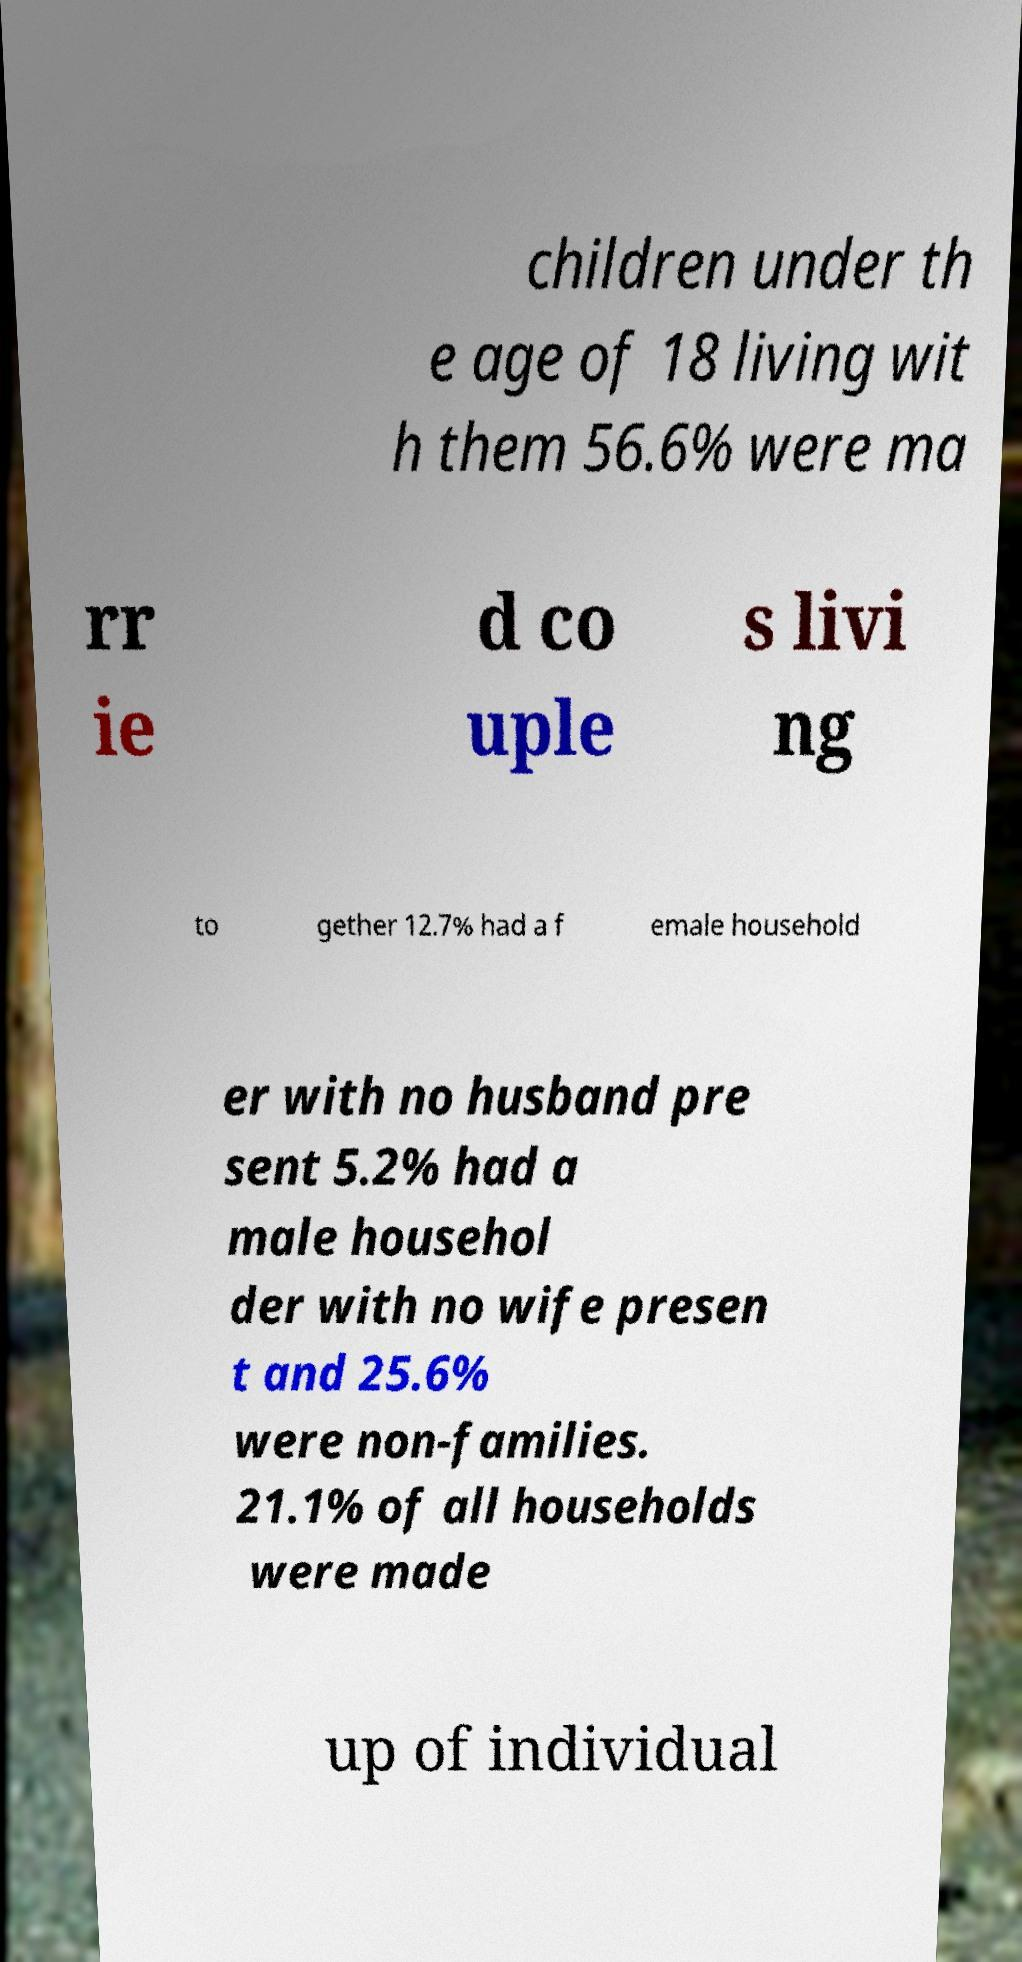There's text embedded in this image that I need extracted. Can you transcribe it verbatim? children under th e age of 18 living wit h them 56.6% were ma rr ie d co uple s livi ng to gether 12.7% had a f emale household er with no husband pre sent 5.2% had a male househol der with no wife presen t and 25.6% were non-families. 21.1% of all households were made up of individual 